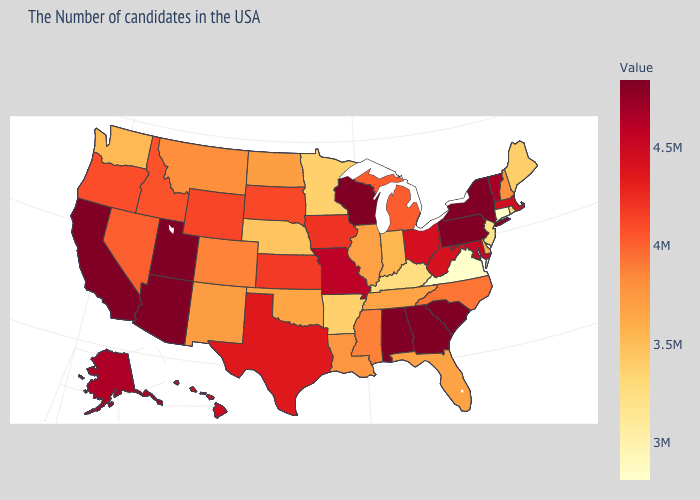Among the states that border South Carolina , which have the lowest value?
Quick response, please. North Carolina. Which states hav the highest value in the Northeast?
Write a very short answer. New York, Pennsylvania. Does the map have missing data?
Keep it brief. No. 